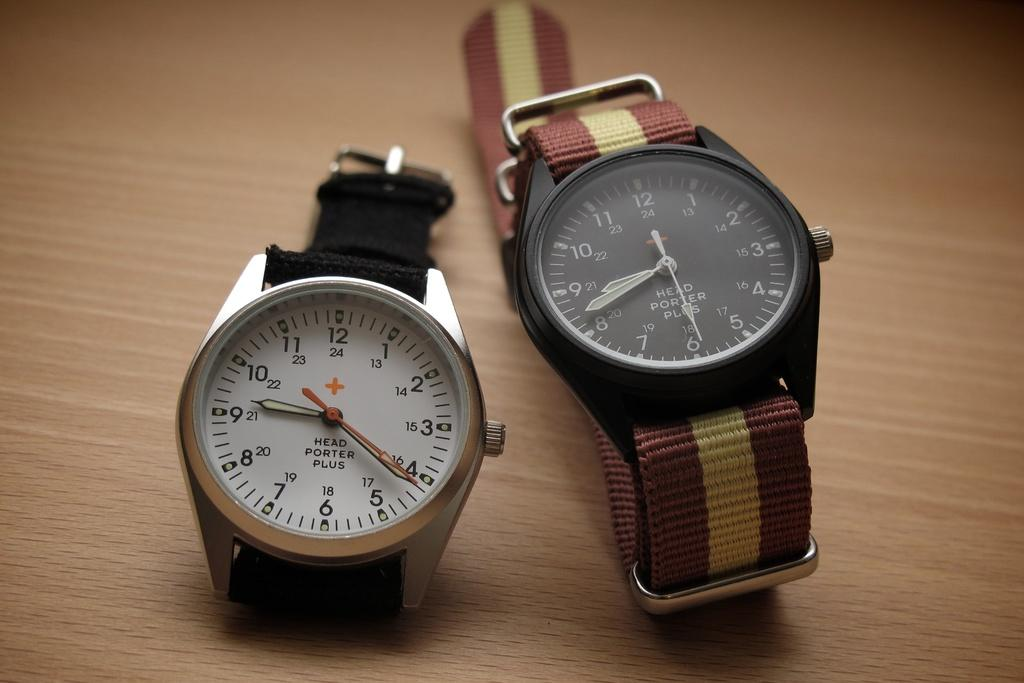Provide a one-sentence caption for the provided image. Two watches from Head Porter plus are on the table. 